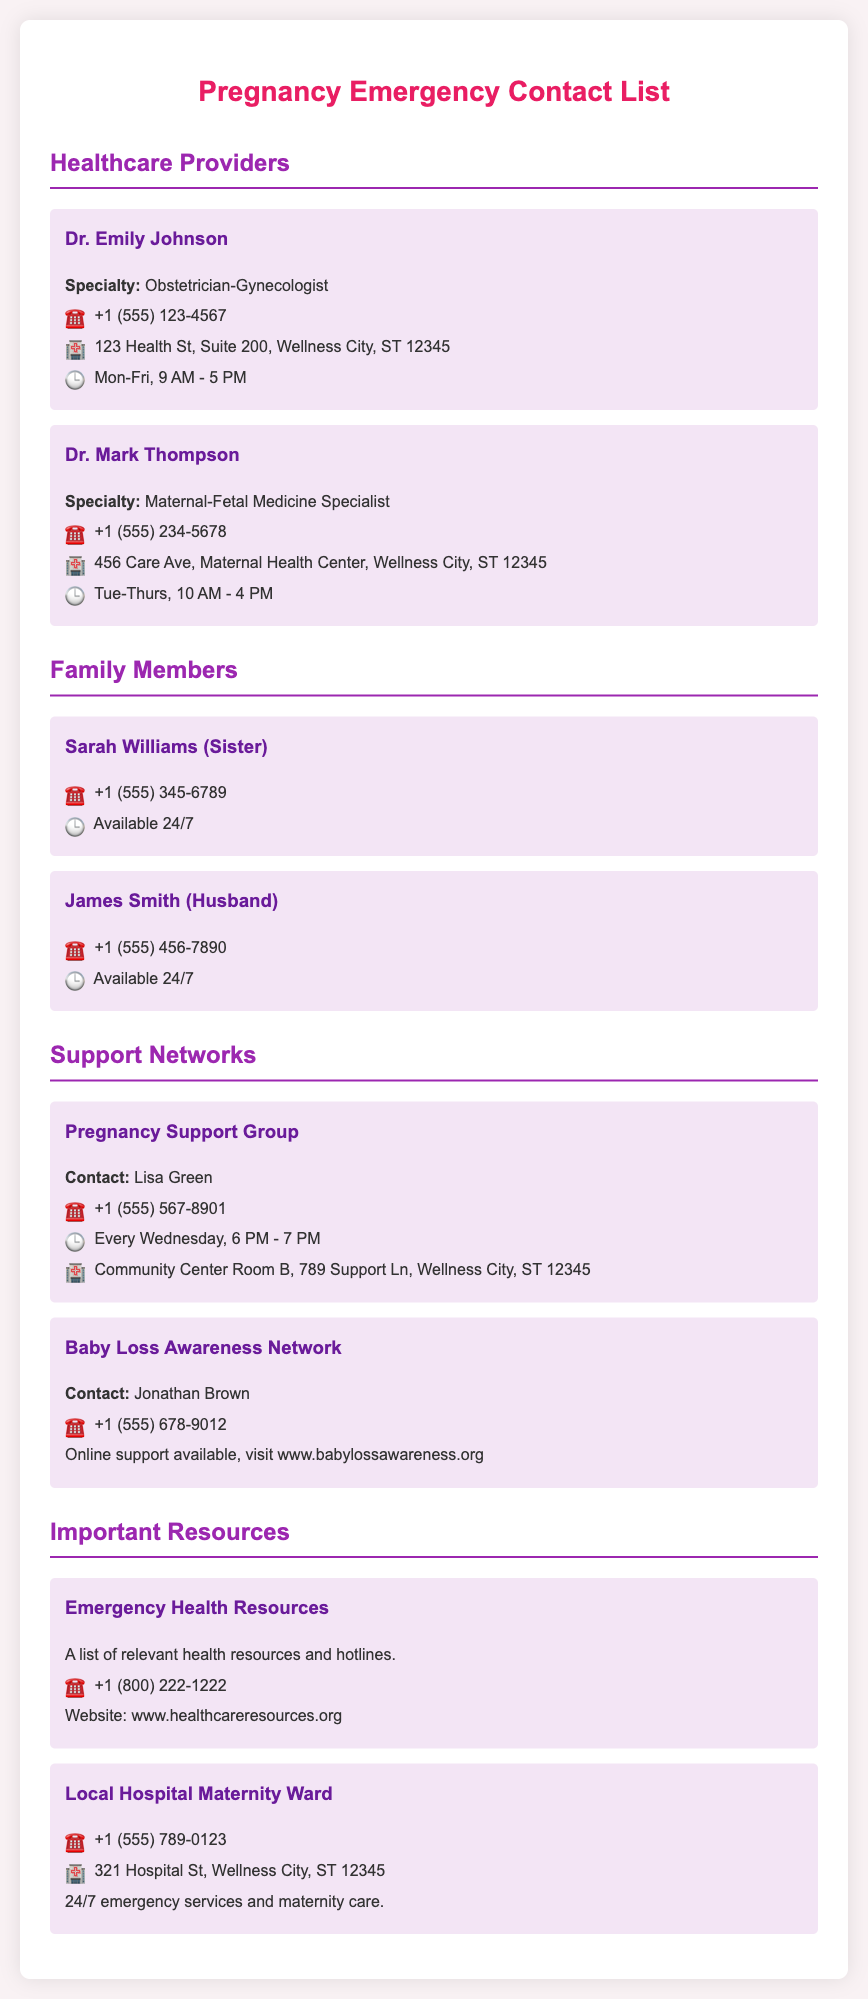what is the name of the obstetrician-gynecologist? The document lists Dr. Emily Johnson as the obstetrician-gynecologist.
Answer: Dr. Emily Johnson what is the phone number of the maternal-fetal medicine specialist? The phone number provided for Dr. Mark Thompson is listed in the document.
Answer: +1 (555) 234-5678 who is available 24/7? The document states that both Sarah Williams and James Smith are available 24/7.
Answer: Sarah Williams and James Smith what is the meeting time for the Pregnancy Support Group? The document mentions that the group meets every Wednesday at 6 PM - 7 PM.
Answer: Every Wednesday, 6 PM - 7 PM what is the address of the Local Hospital Maternity Ward? The address can be found in the contact for the Local Hospital Maternity Ward.
Answer: 321 Hospital St, Wellness City, ST 12345 who can be contacted for online support related to baby loss? The document lists Jonathan Brown as the contact person for online support.
Answer: Jonathan Brown how many healthcare providers are listed in the document? The document includes two healthcare providers in the Healthcare Providers section.
Answer: 2 what specialty is Dr. Mark Thompson? The document specifies that Dr. Mark Thompson is a Maternal-Fetal Medicine Specialist.
Answer: Maternal-Fetal Medicine Specialist what is the contact number for emergency health resources? The contact number provided for Emergency Health Resources is stated in the document.
Answer: +1 (800) 222-1222 